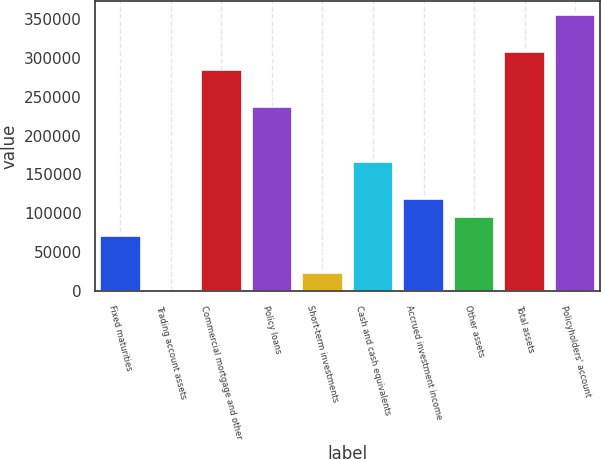Convert chart. <chart><loc_0><loc_0><loc_500><loc_500><bar_chart><fcel>Fixed maturities<fcel>Trading account assets<fcel>Commercial mortgage and other<fcel>Policy loans<fcel>Short-term investments<fcel>Cash and cash equivalents<fcel>Accrued investment income<fcel>Other assets<fcel>Total assets<fcel>Policyholders' account<nl><fcel>71101.8<fcel>150<fcel>283957<fcel>236656<fcel>23800.6<fcel>165704<fcel>118403<fcel>94752.4<fcel>307608<fcel>354909<nl></chart> 